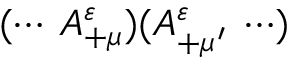<formula> <loc_0><loc_0><loc_500><loc_500>( \cdots \, A _ { + \mu } ^ { \varepsilon } ) ( A _ { + \mu ^ { \prime } } ^ { \varepsilon } \, \cdots )</formula> 